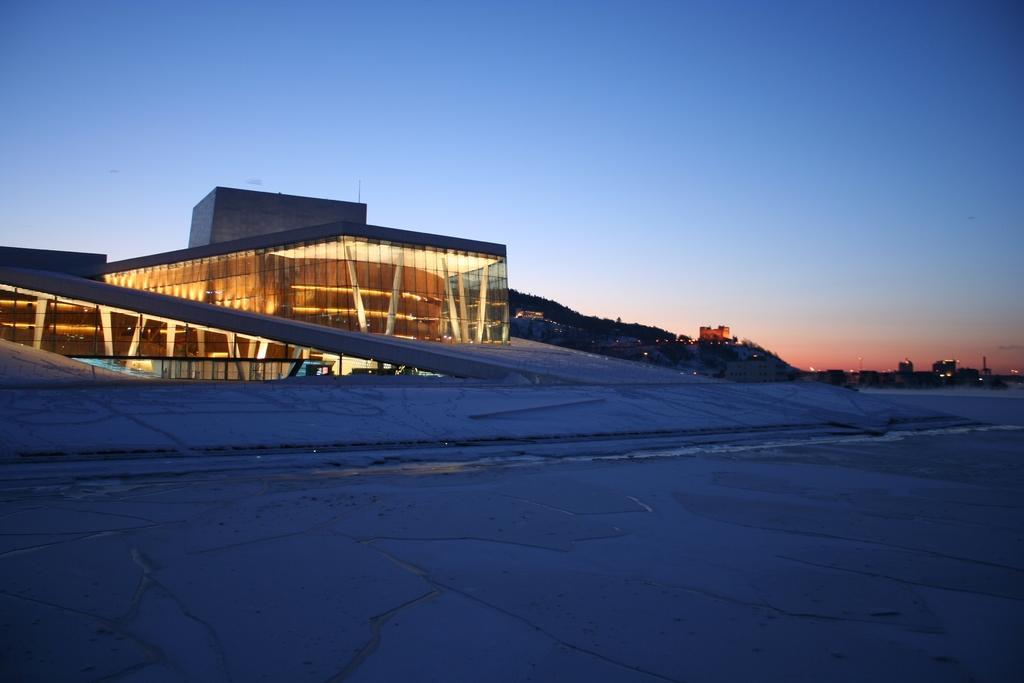Can you describe this image briefly? In this picture we can see road and building. In the background of the image we can see lights, trees and sky. 